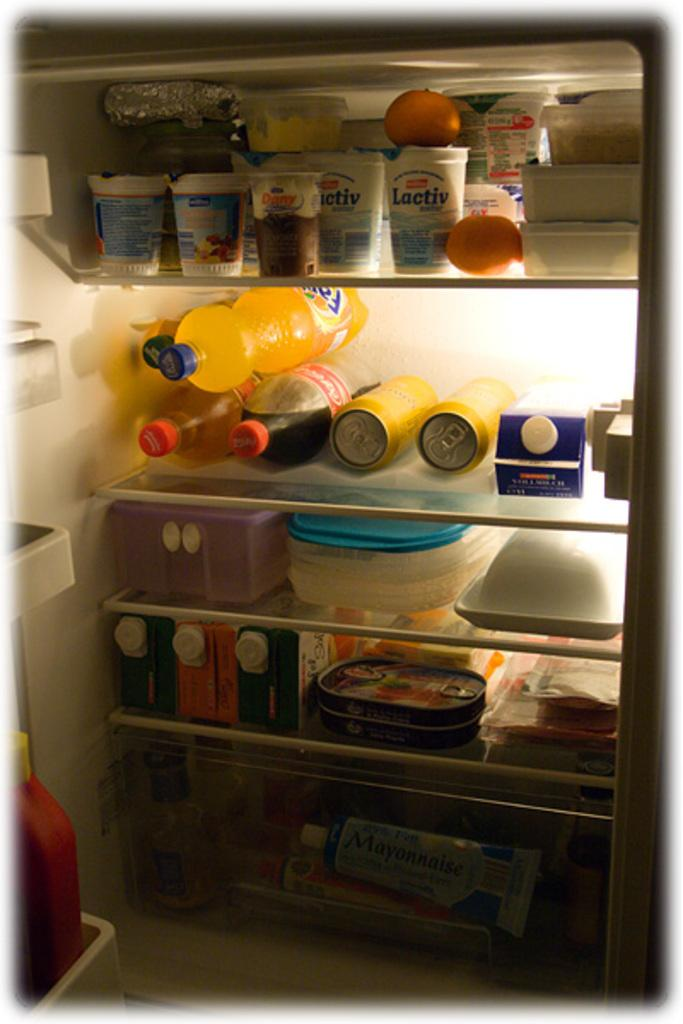<image>
Relay a brief, clear account of the picture shown. the word Lactiv is on the white bottle 